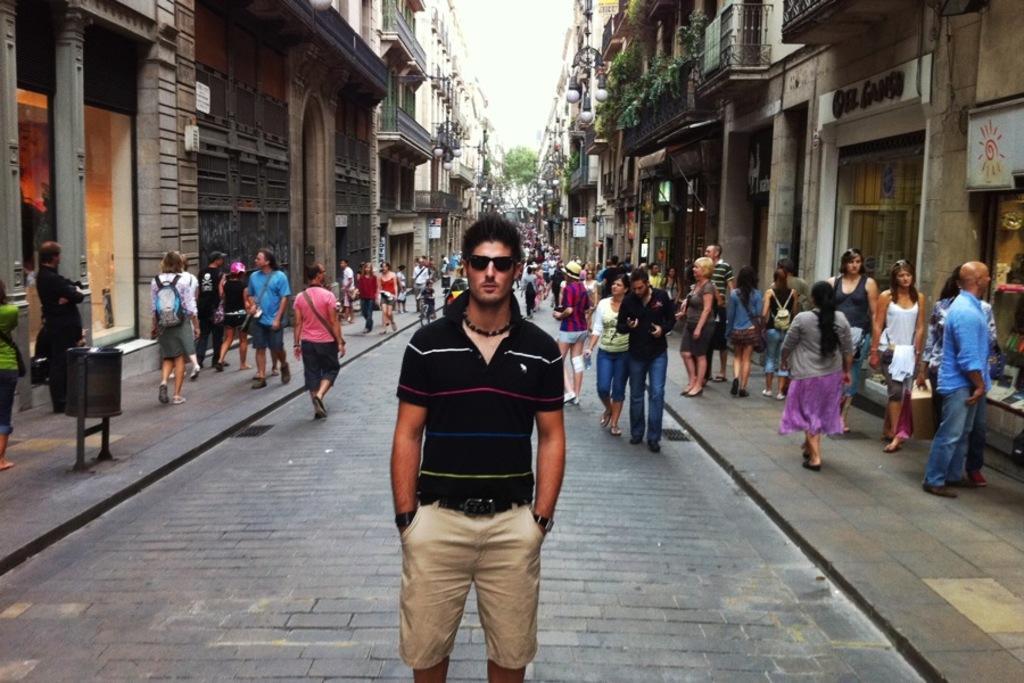Can you describe this image briefly? There is one man standing and wearing a black color t shirt as we can see at the bottom of this image. We can see a crowd in the middle of this image and there are buildings in the background. 